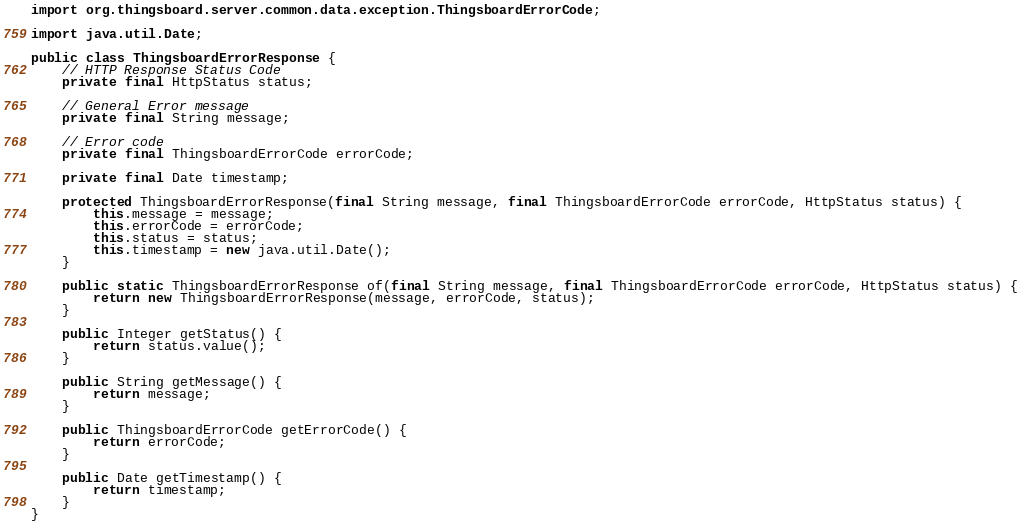Convert code to text. <code><loc_0><loc_0><loc_500><loc_500><_Java_>import org.thingsboard.server.common.data.exception.ThingsboardErrorCode;

import java.util.Date;

public class ThingsboardErrorResponse {
    // HTTP Response Status Code
    private final HttpStatus status;

    // General Error message
    private final String message;

    // Error code
    private final ThingsboardErrorCode errorCode;

    private final Date timestamp;

    protected ThingsboardErrorResponse(final String message, final ThingsboardErrorCode errorCode, HttpStatus status) {
        this.message = message;
        this.errorCode = errorCode;
        this.status = status;
        this.timestamp = new java.util.Date();
    }

    public static ThingsboardErrorResponse of(final String message, final ThingsboardErrorCode errorCode, HttpStatus status) {
        return new ThingsboardErrorResponse(message, errorCode, status);
    }

    public Integer getStatus() {
        return status.value();
    }

    public String getMessage() {
        return message;
    }

    public ThingsboardErrorCode getErrorCode() {
        return errorCode;
    }

    public Date getTimestamp() {
        return timestamp;
    }
}
</code> 